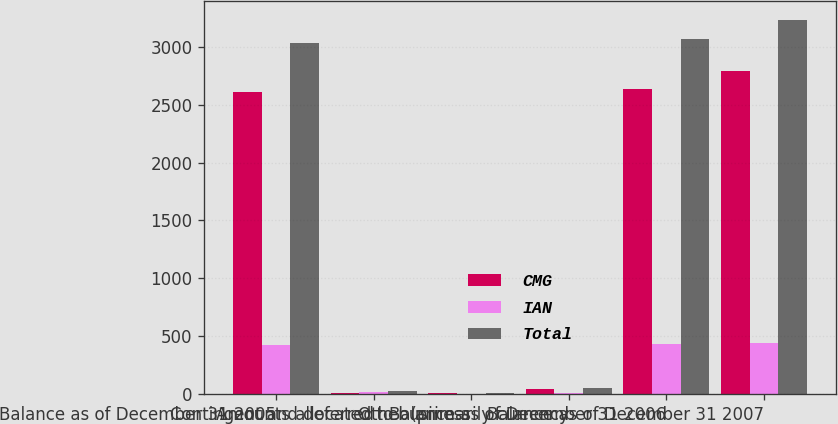Convert chart to OTSL. <chart><loc_0><loc_0><loc_500><loc_500><stacked_bar_chart><ecel><fcel>Balance as of December 31 2005<fcel>Contingent and deferred<fcel>Amounts allocated to business<fcel>Other (primarily currency<fcel>Balance as of December 31 2006<fcel>Balance as of December 31 2007<nl><fcel>CMG<fcel>2612.7<fcel>11.1<fcel>9.1<fcel>45<fcel>2632.5<fcel>2789.7<nl><fcel>IAN<fcel>418.2<fcel>13.2<fcel>2.7<fcel>6.6<fcel>435.3<fcel>441.9<nl><fcel>Total<fcel>3030.9<fcel>24.3<fcel>11.8<fcel>51.6<fcel>3067.8<fcel>3231.6<nl></chart> 